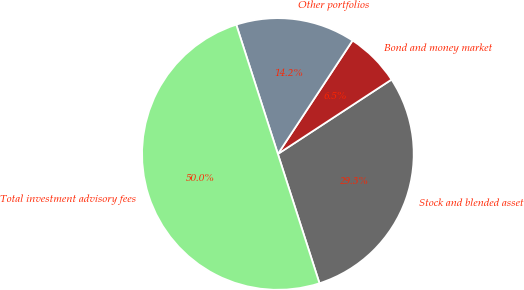Convert chart to OTSL. <chart><loc_0><loc_0><loc_500><loc_500><pie_chart><fcel>Stock and blended asset<fcel>Bond and money market<fcel>Other portfolios<fcel>Total investment advisory fees<nl><fcel>29.27%<fcel>6.51%<fcel>14.22%<fcel>50.0%<nl></chart> 